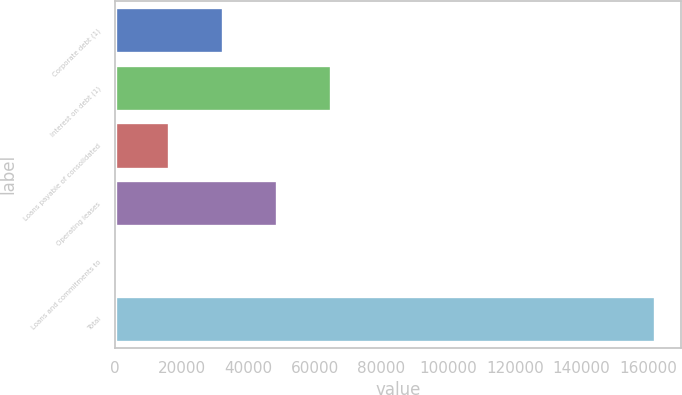<chart> <loc_0><loc_0><loc_500><loc_500><bar_chart><fcel>Corporate debt (1)<fcel>Interest on debt (1)<fcel>Loans payable of consolidated<fcel>Operating leases<fcel>Loans and commitments to<fcel>Total<nl><fcel>32491.8<fcel>64864.6<fcel>16305.4<fcel>48678.2<fcel>119<fcel>161983<nl></chart> 